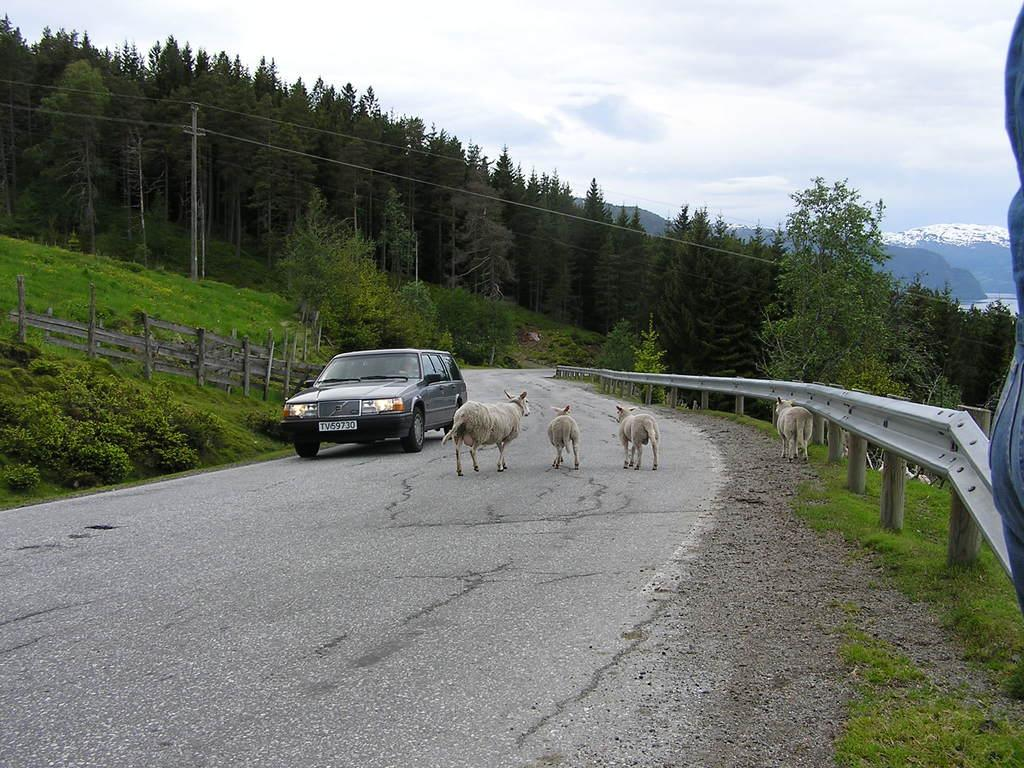What is the main feature of the image? There is a road in the image. What is on the road? There is a car on the road. What else can be seen in the image besides the road and car? There are animals, a railing, plants, trees, an electric pole, and hills in the image. What is visible in the background of the image? The sky is visible in the image. How much profit do the rabbits make in the image? There are no rabbits present in the image, and therefore no profit can be determined. 